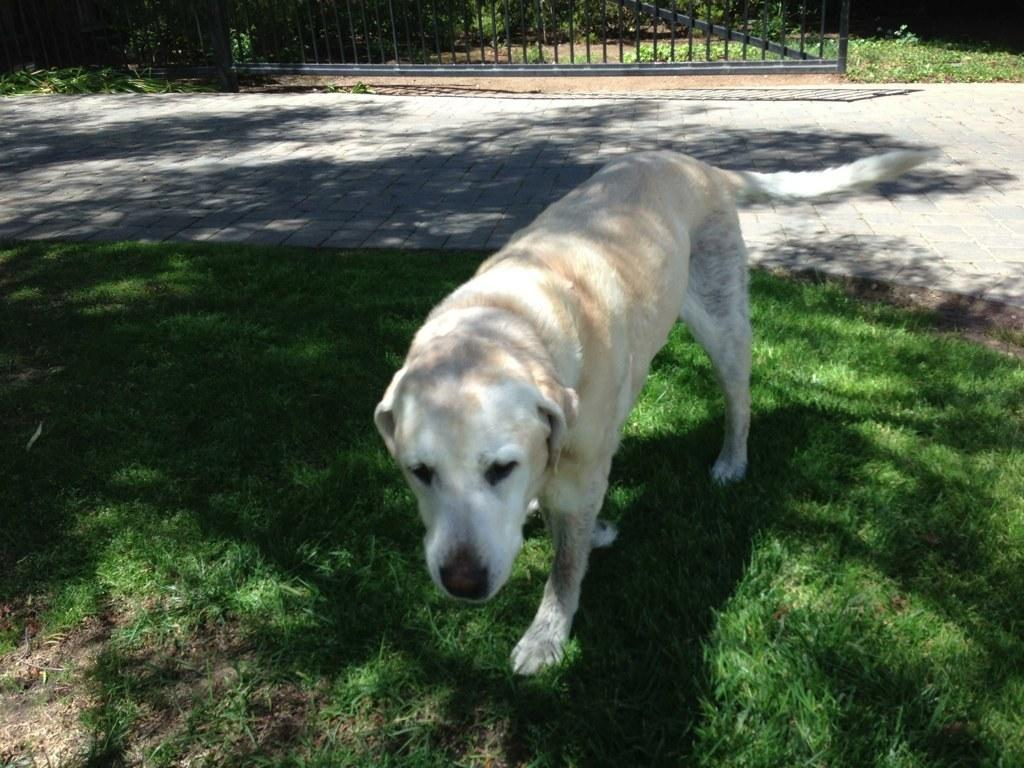What type of animal is present in the image? There is a dog in the image. What color is the dog? The dog is white in color. What type of vegetation is visible at the bottom of the image? There is green grass at the bottom of the image. What can be seen in the background of the image? There is a fencing in the background of the image. What else is visible in the image besides the dog and the grass? There is a road visible in the image. How many cakes are being attacked by the dog in the image? There are no cakes present in the image, nor is the dog attacking anything. 